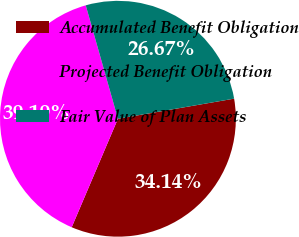Convert chart to OTSL. <chart><loc_0><loc_0><loc_500><loc_500><pie_chart><fcel>Accumulated Benefit Obligation<fcel>Projected Benefit Obligation<fcel>Fair Value of Plan Assets<nl><fcel>34.14%<fcel>39.19%<fcel>26.67%<nl></chart> 